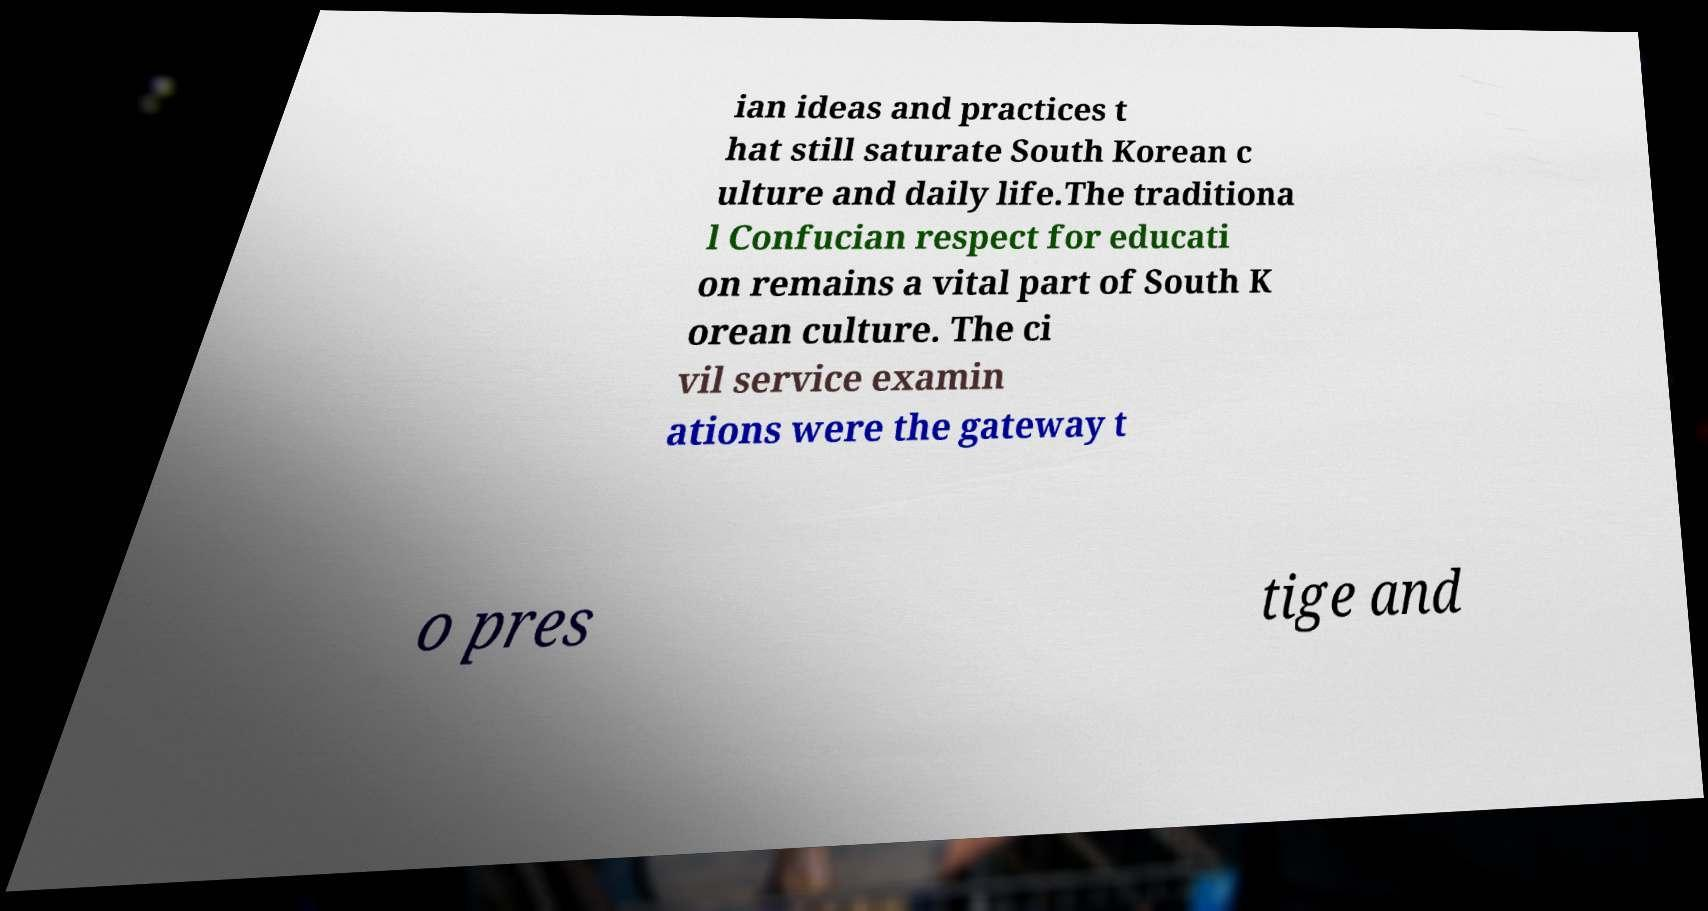What messages or text are displayed in this image? I need them in a readable, typed format. ian ideas and practices t hat still saturate South Korean c ulture and daily life.The traditiona l Confucian respect for educati on remains a vital part of South K orean culture. The ci vil service examin ations were the gateway t o pres tige and 